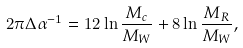<formula> <loc_0><loc_0><loc_500><loc_500>2 \pi \Delta \alpha ^ { - 1 } = 1 2 \ln \frac { M _ { c } } { M _ { W } } + 8 \ln \frac { M _ { R } } { M _ { W } } ,</formula> 